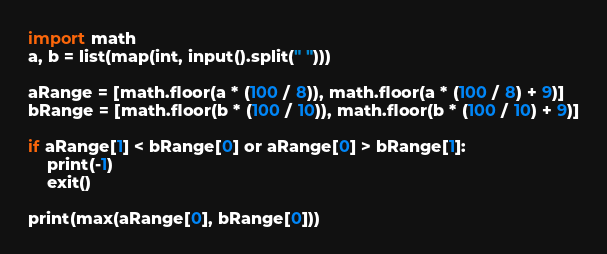Convert code to text. <code><loc_0><loc_0><loc_500><loc_500><_Python_>import math
a, b = list(map(int, input().split(" ")))

aRange = [math.floor(a * (100 / 8)), math.floor(a * (100 / 8) + 9)]
bRange = [math.floor(b * (100 / 10)), math.floor(b * (100 / 10) + 9)]

if aRange[1] < bRange[0] or aRange[0] > bRange[1]:
    print(-1)
    exit()

print(max(aRange[0], bRange[0]))</code> 